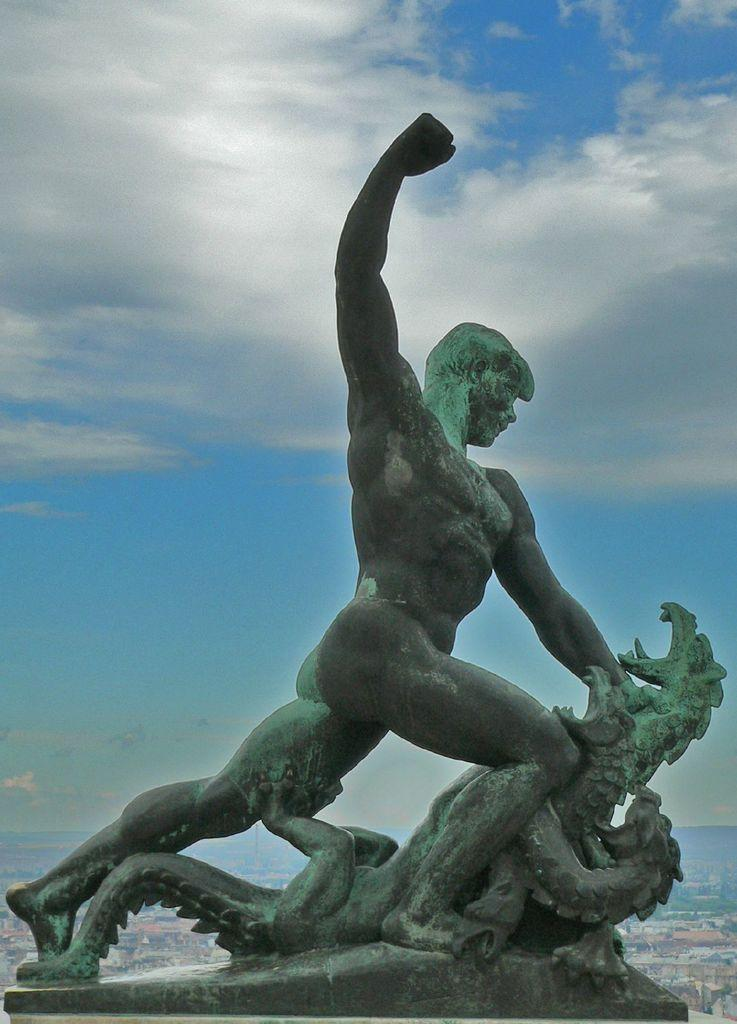What is the main subject in the image? There is a statue in the image. What can be seen in the background of the image? There is a cloudy sky visible in the background of the image. What type of seed can be seen growing on the statue in the image? There is no seed visible on the statue in the image. What color is the dust covering the statue in the image? There is no dust visible on the statue in the image. 